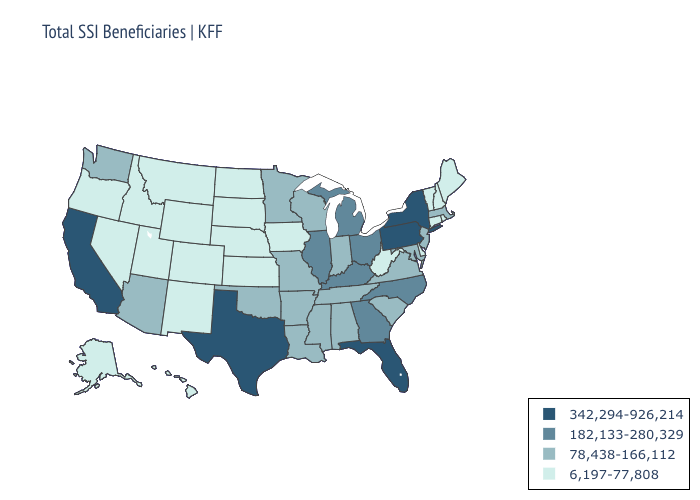Does Indiana have the highest value in the MidWest?
Concise answer only. No. Among the states that border Tennessee , does Arkansas have the highest value?
Be succinct. No. What is the lowest value in the South?
Quick response, please. 6,197-77,808. Among the states that border Maine , which have the highest value?
Answer briefly. New Hampshire. Does the first symbol in the legend represent the smallest category?
Short answer required. No. Does Minnesota have the highest value in the USA?
Keep it brief. No. Does Montana have a lower value than Louisiana?
Keep it brief. Yes. Among the states that border Kentucky , which have the highest value?
Give a very brief answer. Illinois, Ohio. Name the states that have a value in the range 78,438-166,112?
Short answer required. Alabama, Arizona, Arkansas, Indiana, Louisiana, Maryland, Massachusetts, Minnesota, Mississippi, Missouri, New Jersey, Oklahoma, South Carolina, Tennessee, Virginia, Washington, Wisconsin. What is the value of Hawaii?
Quick response, please. 6,197-77,808. Does Massachusetts have the highest value in the Northeast?
Quick response, please. No. What is the value of Nebraska?
Keep it brief. 6,197-77,808. What is the value of North Dakota?
Write a very short answer. 6,197-77,808. What is the value of California?
Be succinct. 342,294-926,214. Which states have the highest value in the USA?
Write a very short answer. California, Florida, New York, Pennsylvania, Texas. 